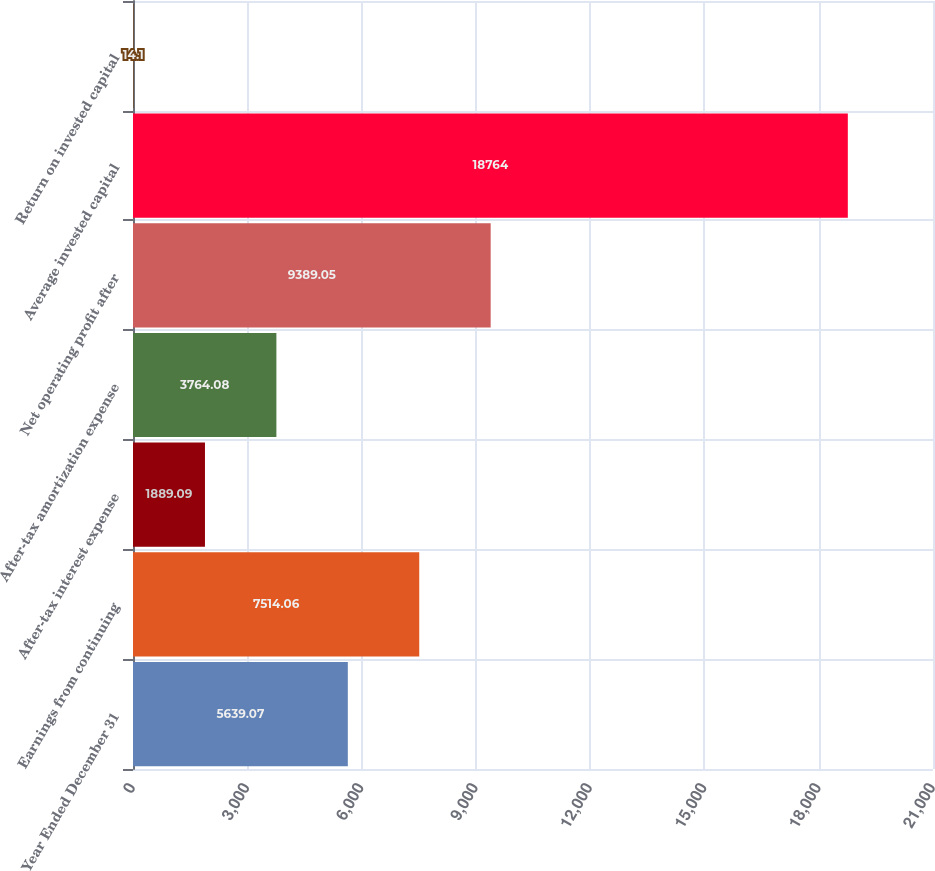Convert chart. <chart><loc_0><loc_0><loc_500><loc_500><bar_chart><fcel>Year Ended December 31<fcel>Earnings from continuing<fcel>After-tax interest expense<fcel>After-tax amortization expense<fcel>Net operating profit after<fcel>Average invested capital<fcel>Return on invested capital<nl><fcel>5639.07<fcel>7514.06<fcel>1889.09<fcel>3764.08<fcel>9389.05<fcel>18764<fcel>14.1<nl></chart> 